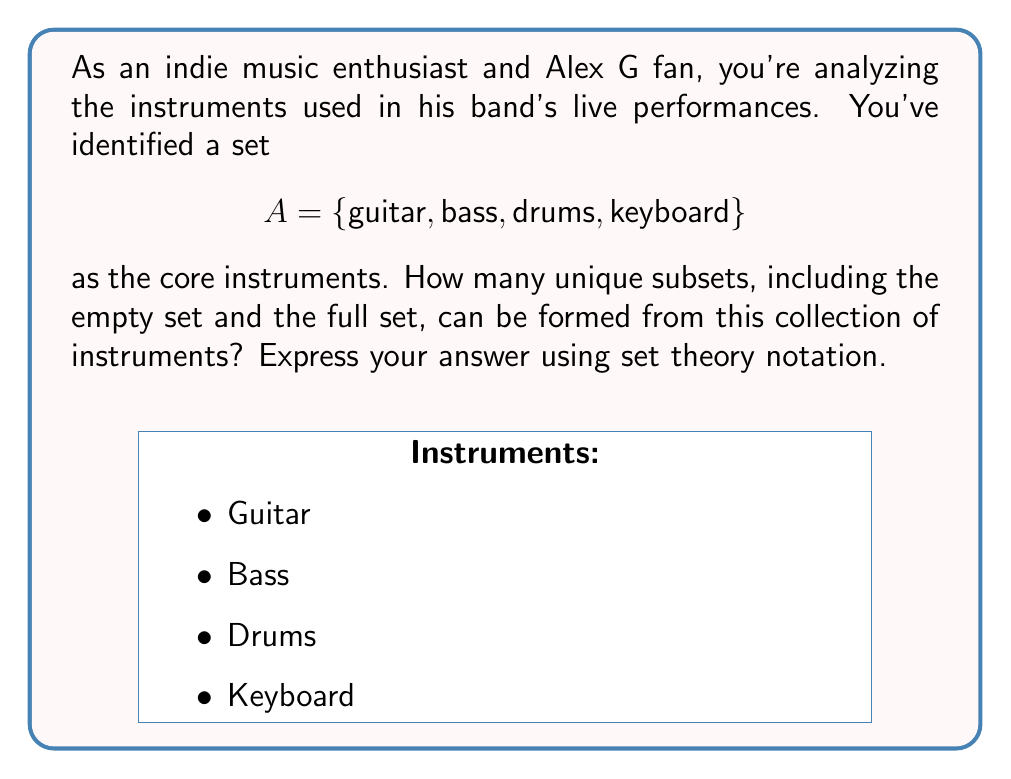Provide a solution to this math problem. Let's approach this step-by-step:

1) First, recall that the power set of a set A, denoted as P(A), is the set of all possible subsets of A, including the empty set ∅ and A itself.

2) To find the number of elements in the power set, we use the formula:
   $$|P(A)| = 2^n$$
   where n is the number of elements in the original set A.

3) In this case, set A has 4 elements: {guitar, bass, drums, keyboard}

4) Therefore, n = 4

5) Applying the formula:
   $$|P(A)| = 2^4 = 16$$

6) To express this using set theory notation, we write:
   $$|P(A)| = 2^{|A|}$$

7) The 16 subsets are:
   ∅
   {guitar}
   {bass}
   {drums}
   {keyboard}
   {guitar, bass}
   {guitar, drums}
   {guitar, keyboard}
   {bass, drums}
   {bass, keyboard}
   {drums, keyboard}
   {guitar, bass, drums}
   {guitar, bass, keyboard}
   {guitar, drums, keyboard}
   {bass, drums, keyboard}
   {guitar, bass, drums, keyboard}

These represent all possible combinations of instruments that could be used in different arrangements or stripped-down versions of Alex G's songs.
Answer: $$|P(A)| = 2^{|A|} = 16$$ 